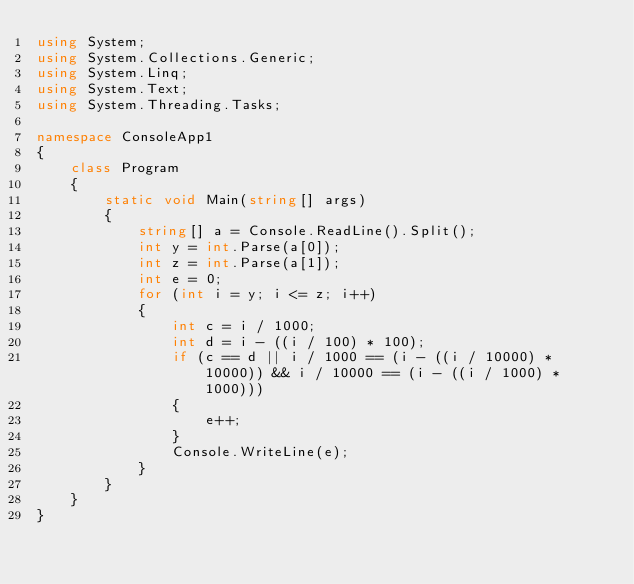Convert code to text. <code><loc_0><loc_0><loc_500><loc_500><_C#_>using System;
using System.Collections.Generic;
using System.Linq;
using System.Text;
using System.Threading.Tasks;

namespace ConsoleApp1
{
    class Program
    {
        static void Main(string[] args)
        {
            string[] a = Console.ReadLine().Split();
            int y = int.Parse(a[0]);
            int z = int.Parse(a[1]);
            int e = 0;
            for (int i = y; i <= z; i++)
            {
                int c = i / 1000;
                int d = i - ((i / 100) * 100);
                if (c == d || i / 1000 == (i - ((i / 10000) * 10000)) && i / 10000 == (i - ((i / 1000) * 1000)))
                {
                    e++;
                }
                Console.WriteLine(e);
            }
        }
    }
}</code> 